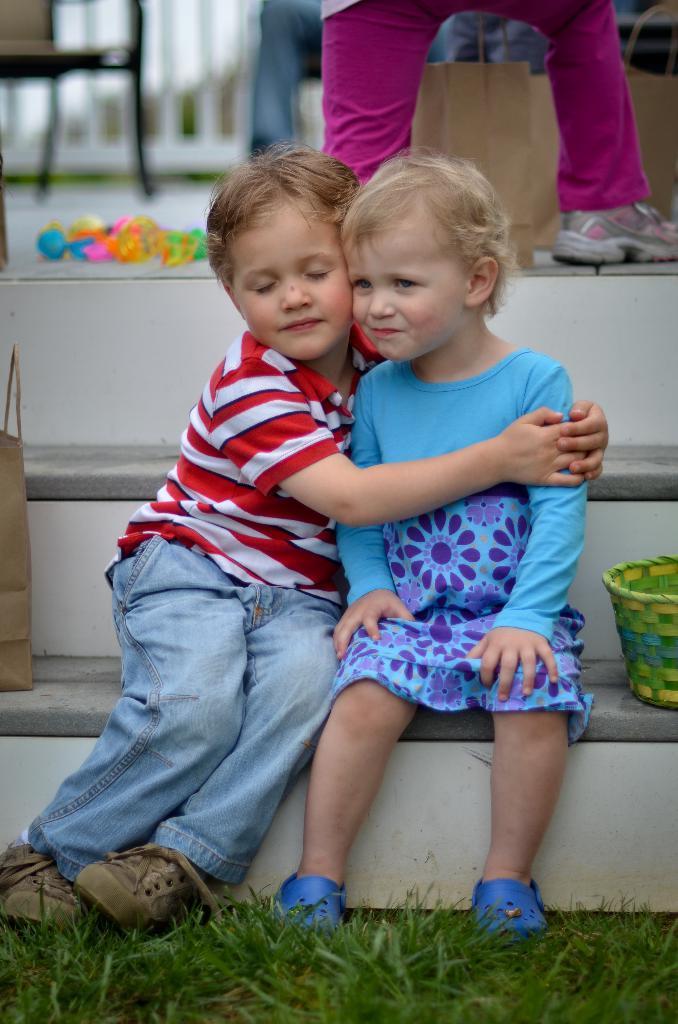Describe this image in one or two sentences. In this image I can see two children are sitting. I can also see grass, a green basket, few carry bags and few other things. I can also see one person over here. 